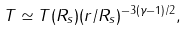Convert formula to latex. <formula><loc_0><loc_0><loc_500><loc_500>T \simeq T ( R _ { s } ) ( r / R _ { s } ) ^ { - 3 ( \gamma - 1 ) / 2 } ,</formula> 